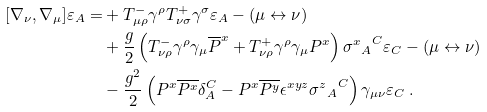<formula> <loc_0><loc_0><loc_500><loc_500>[ \nabla _ { \nu } , \nabla _ { \mu } ] \varepsilon _ { A } = & + T ^ { - } _ { \mu \rho } \gamma ^ { \rho } T ^ { + } _ { \nu \sigma } \gamma ^ { \sigma } \varepsilon _ { A } - ( \mu \leftrightarrow \nu ) \\ & + \frac { g } { 2 } \left ( T ^ { - } _ { \nu \rho } \gamma ^ { \rho } \gamma _ { \mu } \overline { P } ^ { x } + T ^ { + } _ { \nu \rho } \gamma ^ { \rho } \gamma _ { \mu } P ^ { x } \right ) { { \sigma ^ { x } } _ { A } } ^ { C } \varepsilon _ { C } - ( \mu \leftrightarrow \nu ) \\ & - \frac { g ^ { 2 } } 2 \left ( P ^ { x } \overline { P ^ { x } } \delta _ { A } ^ { C } - P ^ { x } \overline { P ^ { y } } \epsilon ^ { x y z } { { \sigma ^ { z } } _ { A } } ^ { C } \right ) \gamma _ { \mu \nu } \varepsilon _ { C } \ .</formula> 